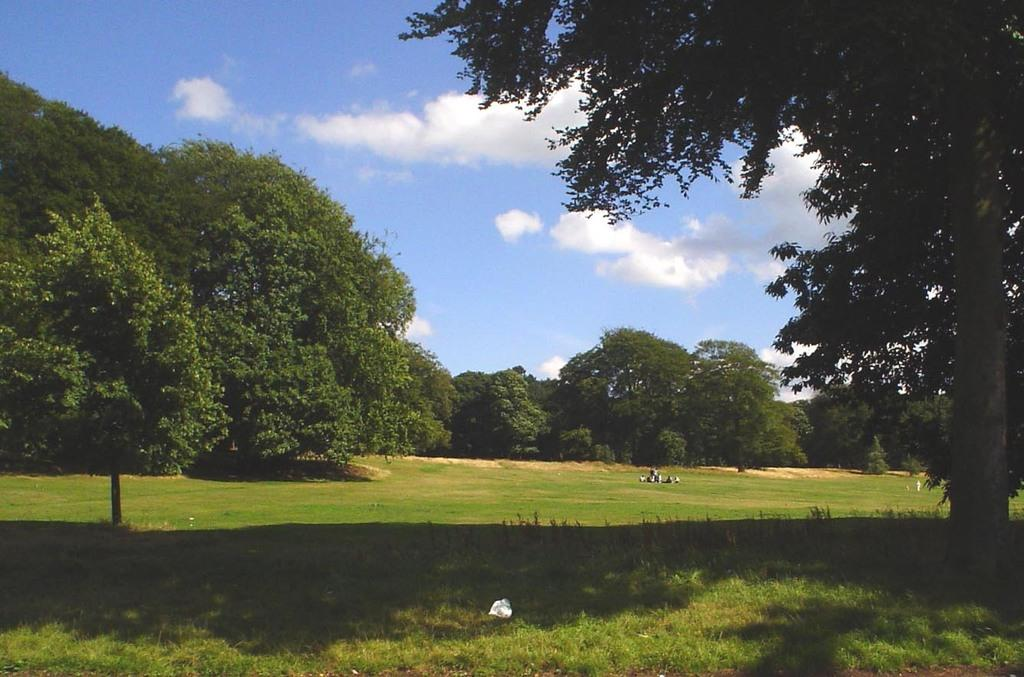What is the main feature in the center of the image? There are trees in the center of the image. What type of vegetation is at the bottom of the image? There is grass at the bottom of the image. What can be seen in the background of the image? The sky is visible in the background of the image. Who is the creator of the voyage depicted in the image? There is no voyage depicted in the image, so there is no creator to mention. Can you tell me the color of the tank in the image? There is no tank present in the image. 